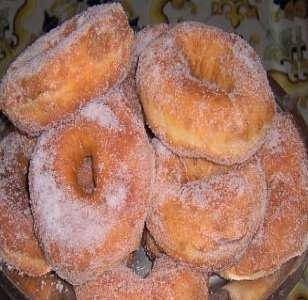Describe the objects in this image and their specific colors. I can see donut in black, lightpink, salmon, and darkgray tones, donut in black, tan, salmon, and brown tones, donut in black, salmon, and gray tones, donut in black and salmon tones, and donut in black and salmon tones in this image. 